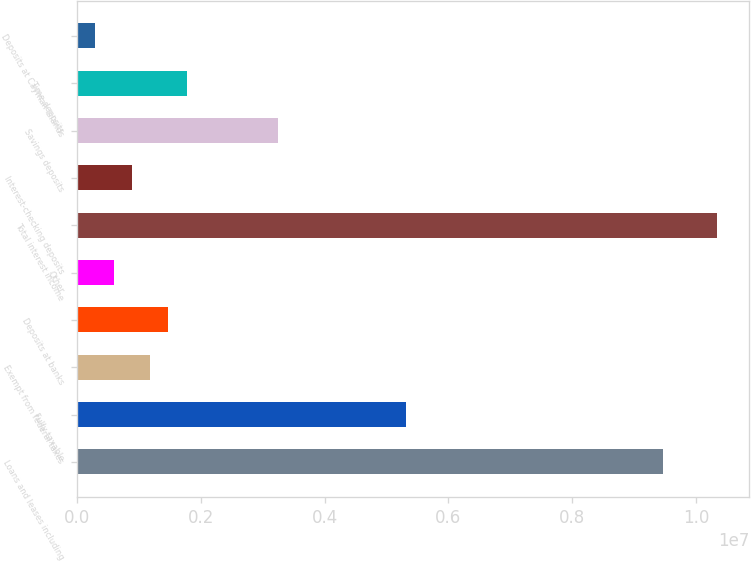Convert chart to OTSL. <chart><loc_0><loc_0><loc_500><loc_500><bar_chart><fcel>Loans and leases including<fcel>Fully taxable<fcel>Exempt from federal taxes<fcel>Deposits at banks<fcel>Other<fcel>Total interest income<fcel>Interest-checking deposits<fcel>Savings deposits<fcel>Time deposits<fcel>Deposits at Cayman Islands<nl><fcel>9.46178e+06<fcel>5.3223e+06<fcel>1.18281e+06<fcel>1.47849e+06<fcel>591456<fcel>1.03488e+07<fcel>887134<fcel>3.25255e+06<fcel>1.77417e+06<fcel>295779<nl></chart> 